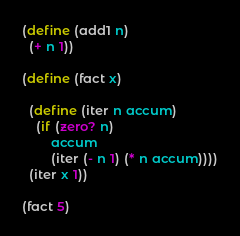Convert code to text. <code><loc_0><loc_0><loc_500><loc_500><_Scheme_>(define (add1 n)
  (+ n 1))

(define (fact x)

  (define (iter n accum)
    (if (zero? n)
        accum
        (iter (- n 1) (* n accum))))
  (iter x 1))

(fact 5)

</code> 